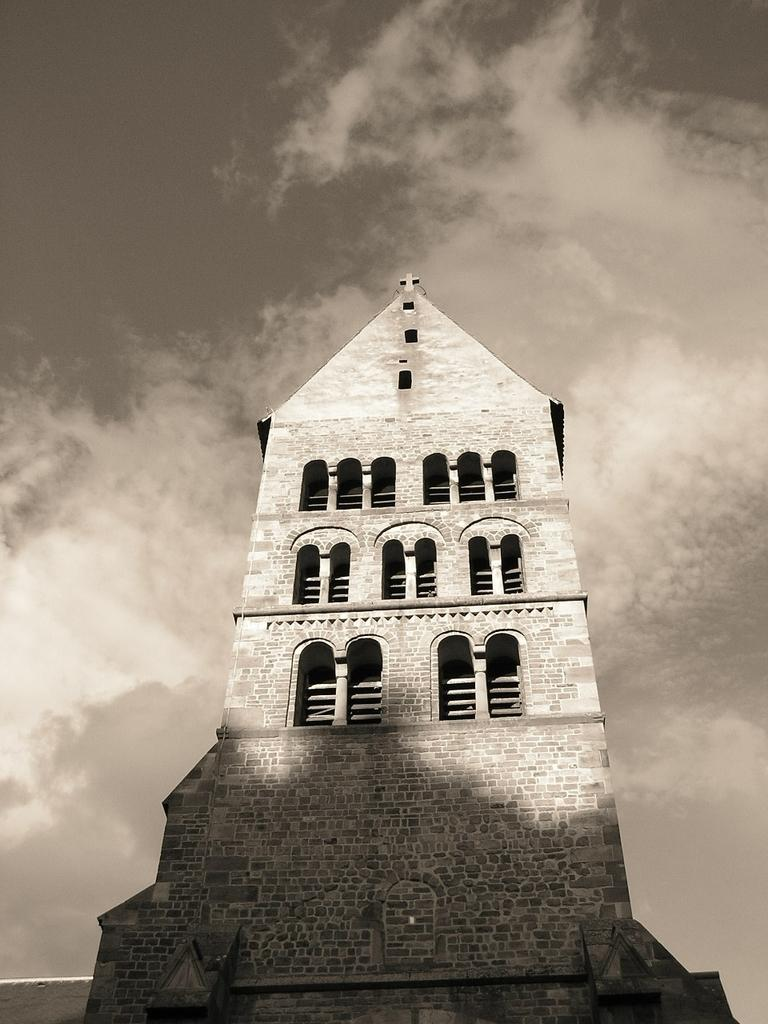What is the main subject in the middle of the image? There is a building in the middle of the image. What can be seen in the sky in the background of the image? There are clouds visible in the sky in the background of the image. How many frogs are jumping around the building in the image? There are no frogs present in the image; it only features a building and clouds in the sky. 